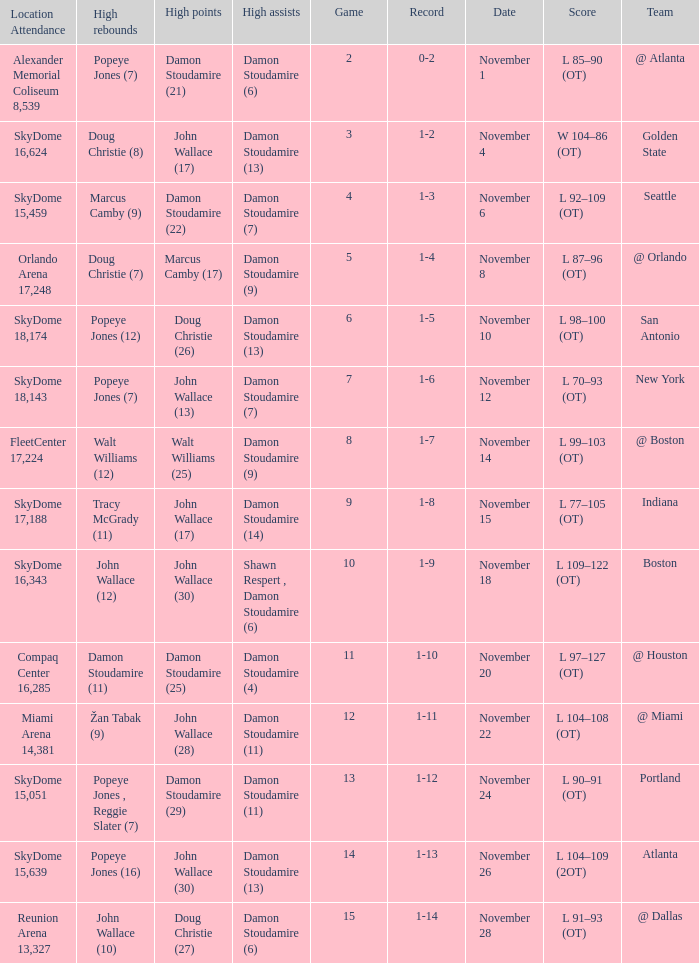How many games did the team play when they were 1-3? 1.0. 